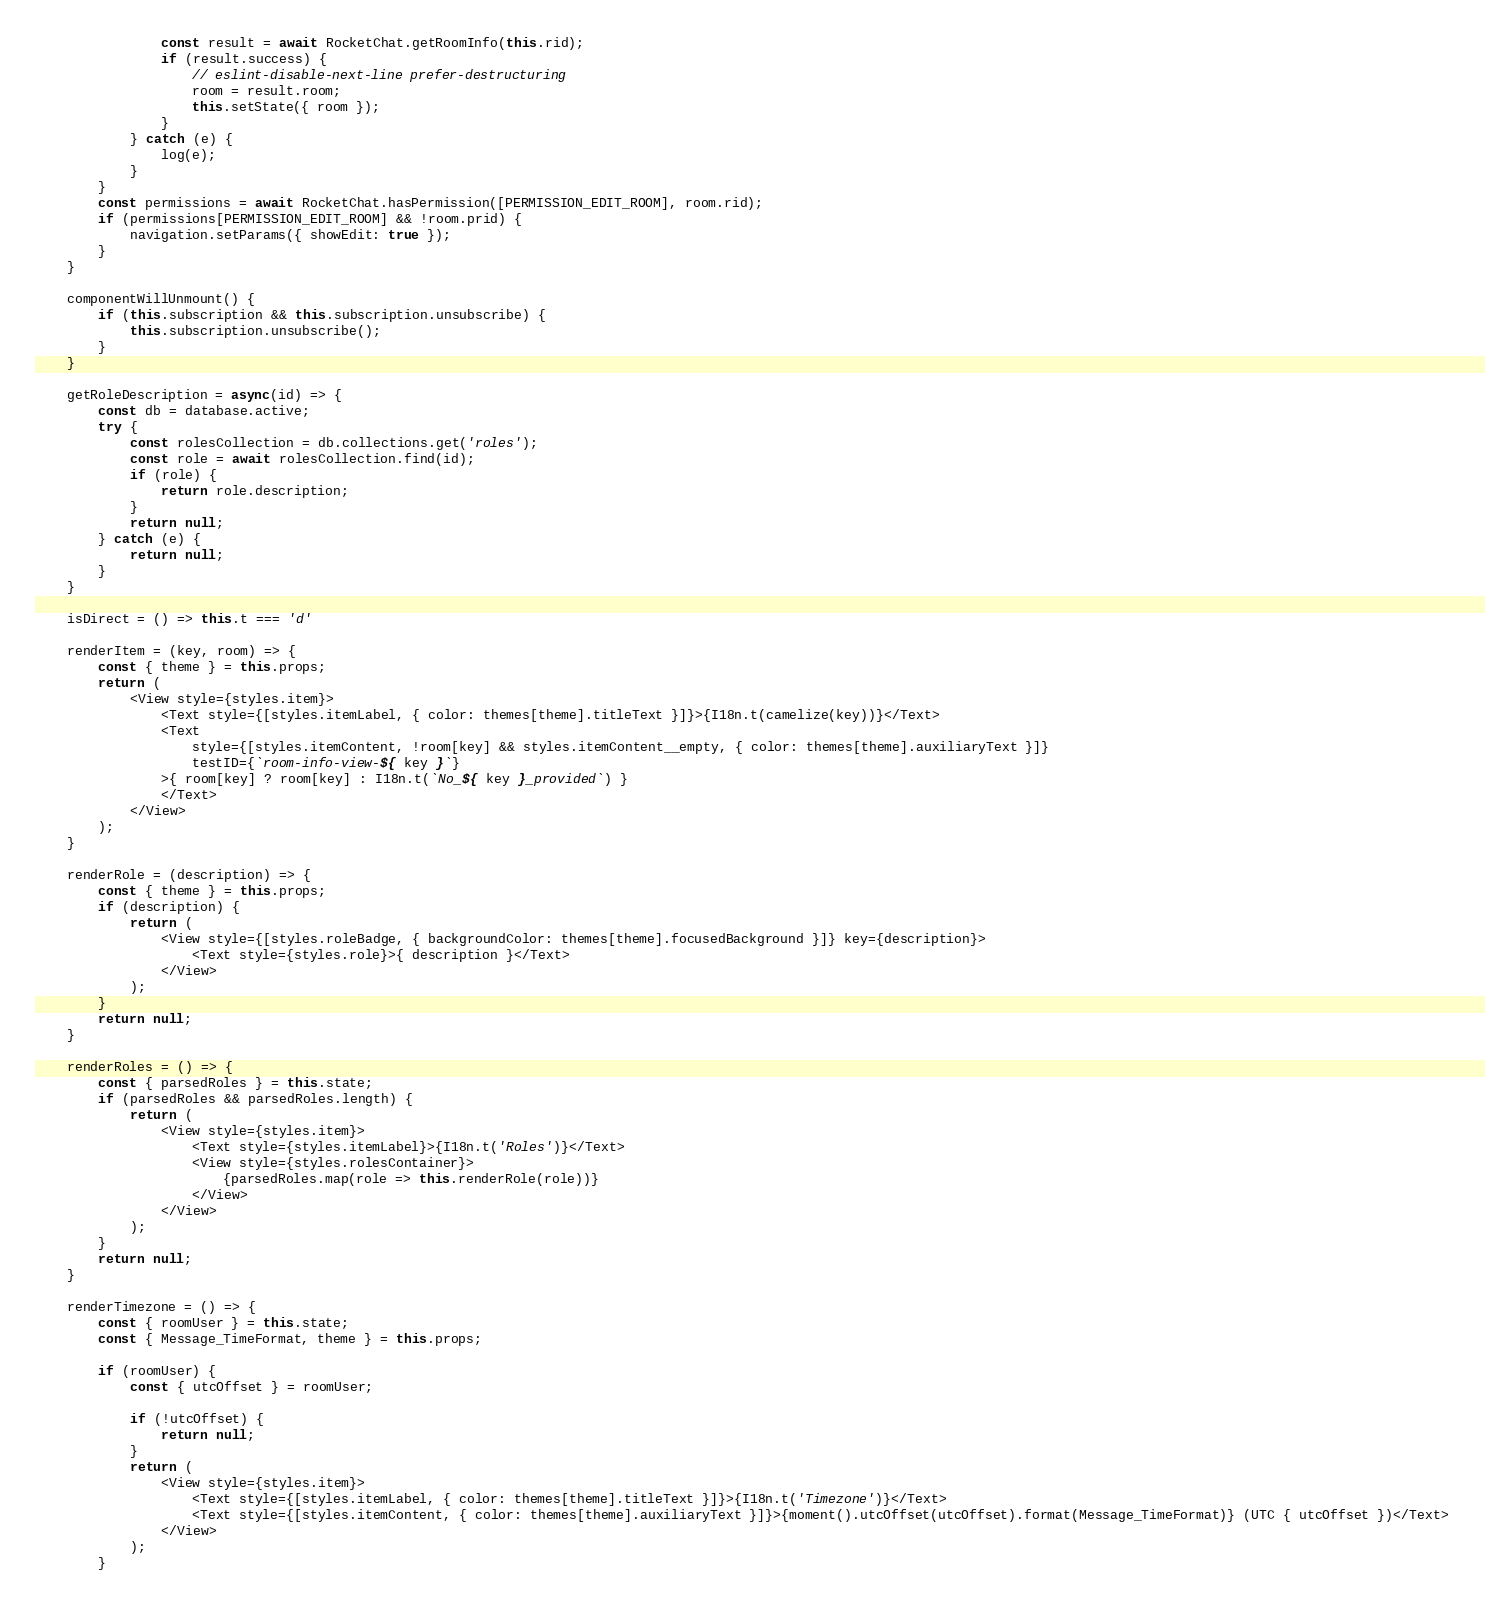<code> <loc_0><loc_0><loc_500><loc_500><_JavaScript_>				const result = await RocketChat.getRoomInfo(this.rid);
				if (result.success) {
					// eslint-disable-next-line prefer-destructuring
					room = result.room;
					this.setState({ room });
				}
			} catch (e) {
				log(e);
			}
		}
		const permissions = await RocketChat.hasPermission([PERMISSION_EDIT_ROOM], room.rid);
		if (permissions[PERMISSION_EDIT_ROOM] && !room.prid) {
			navigation.setParams({ showEdit: true });
		}
	}

	componentWillUnmount() {
		if (this.subscription && this.subscription.unsubscribe) {
			this.subscription.unsubscribe();
		}
	}

	getRoleDescription = async(id) => {
		const db = database.active;
		try {
			const rolesCollection = db.collections.get('roles');
			const role = await rolesCollection.find(id);
			if (role) {
				return role.description;
			}
			return null;
		} catch (e) {
			return null;
		}
	}

	isDirect = () => this.t === 'd'

	renderItem = (key, room) => {
		const { theme } = this.props;
		return (
			<View style={styles.item}>
				<Text style={[styles.itemLabel, { color: themes[theme].titleText }]}>{I18n.t(camelize(key))}</Text>
				<Text
					style={[styles.itemContent, !room[key] && styles.itemContent__empty, { color: themes[theme].auxiliaryText }]}
					testID={`room-info-view-${ key }`}
				>{ room[key] ? room[key] : I18n.t(`No_${ key }_provided`) }
				</Text>
			</View>
		);
	}

	renderRole = (description) => {
		const { theme } = this.props;
		if (description) {
			return (
				<View style={[styles.roleBadge, { backgroundColor: themes[theme].focusedBackground }]} key={description}>
					<Text style={styles.role}>{ description }</Text>
				</View>
			);
		}
		return null;
	}

	renderRoles = () => {
		const { parsedRoles } = this.state;
		if (parsedRoles && parsedRoles.length) {
			return (
				<View style={styles.item}>
					<Text style={styles.itemLabel}>{I18n.t('Roles')}</Text>
					<View style={styles.rolesContainer}>
						{parsedRoles.map(role => this.renderRole(role))}
					</View>
				</View>
			);
		}
		return null;
	}

	renderTimezone = () => {
		const { roomUser } = this.state;
		const { Message_TimeFormat, theme } = this.props;

		if (roomUser) {
			const { utcOffset } = roomUser;

			if (!utcOffset) {
				return null;
			}
			return (
				<View style={styles.item}>
					<Text style={[styles.itemLabel, { color: themes[theme].titleText }]}>{I18n.t('Timezone')}</Text>
					<Text style={[styles.itemContent, { color: themes[theme].auxiliaryText }]}>{moment().utcOffset(utcOffset).format(Message_TimeFormat)} (UTC { utcOffset })</Text>
				</View>
			);
		}</code> 